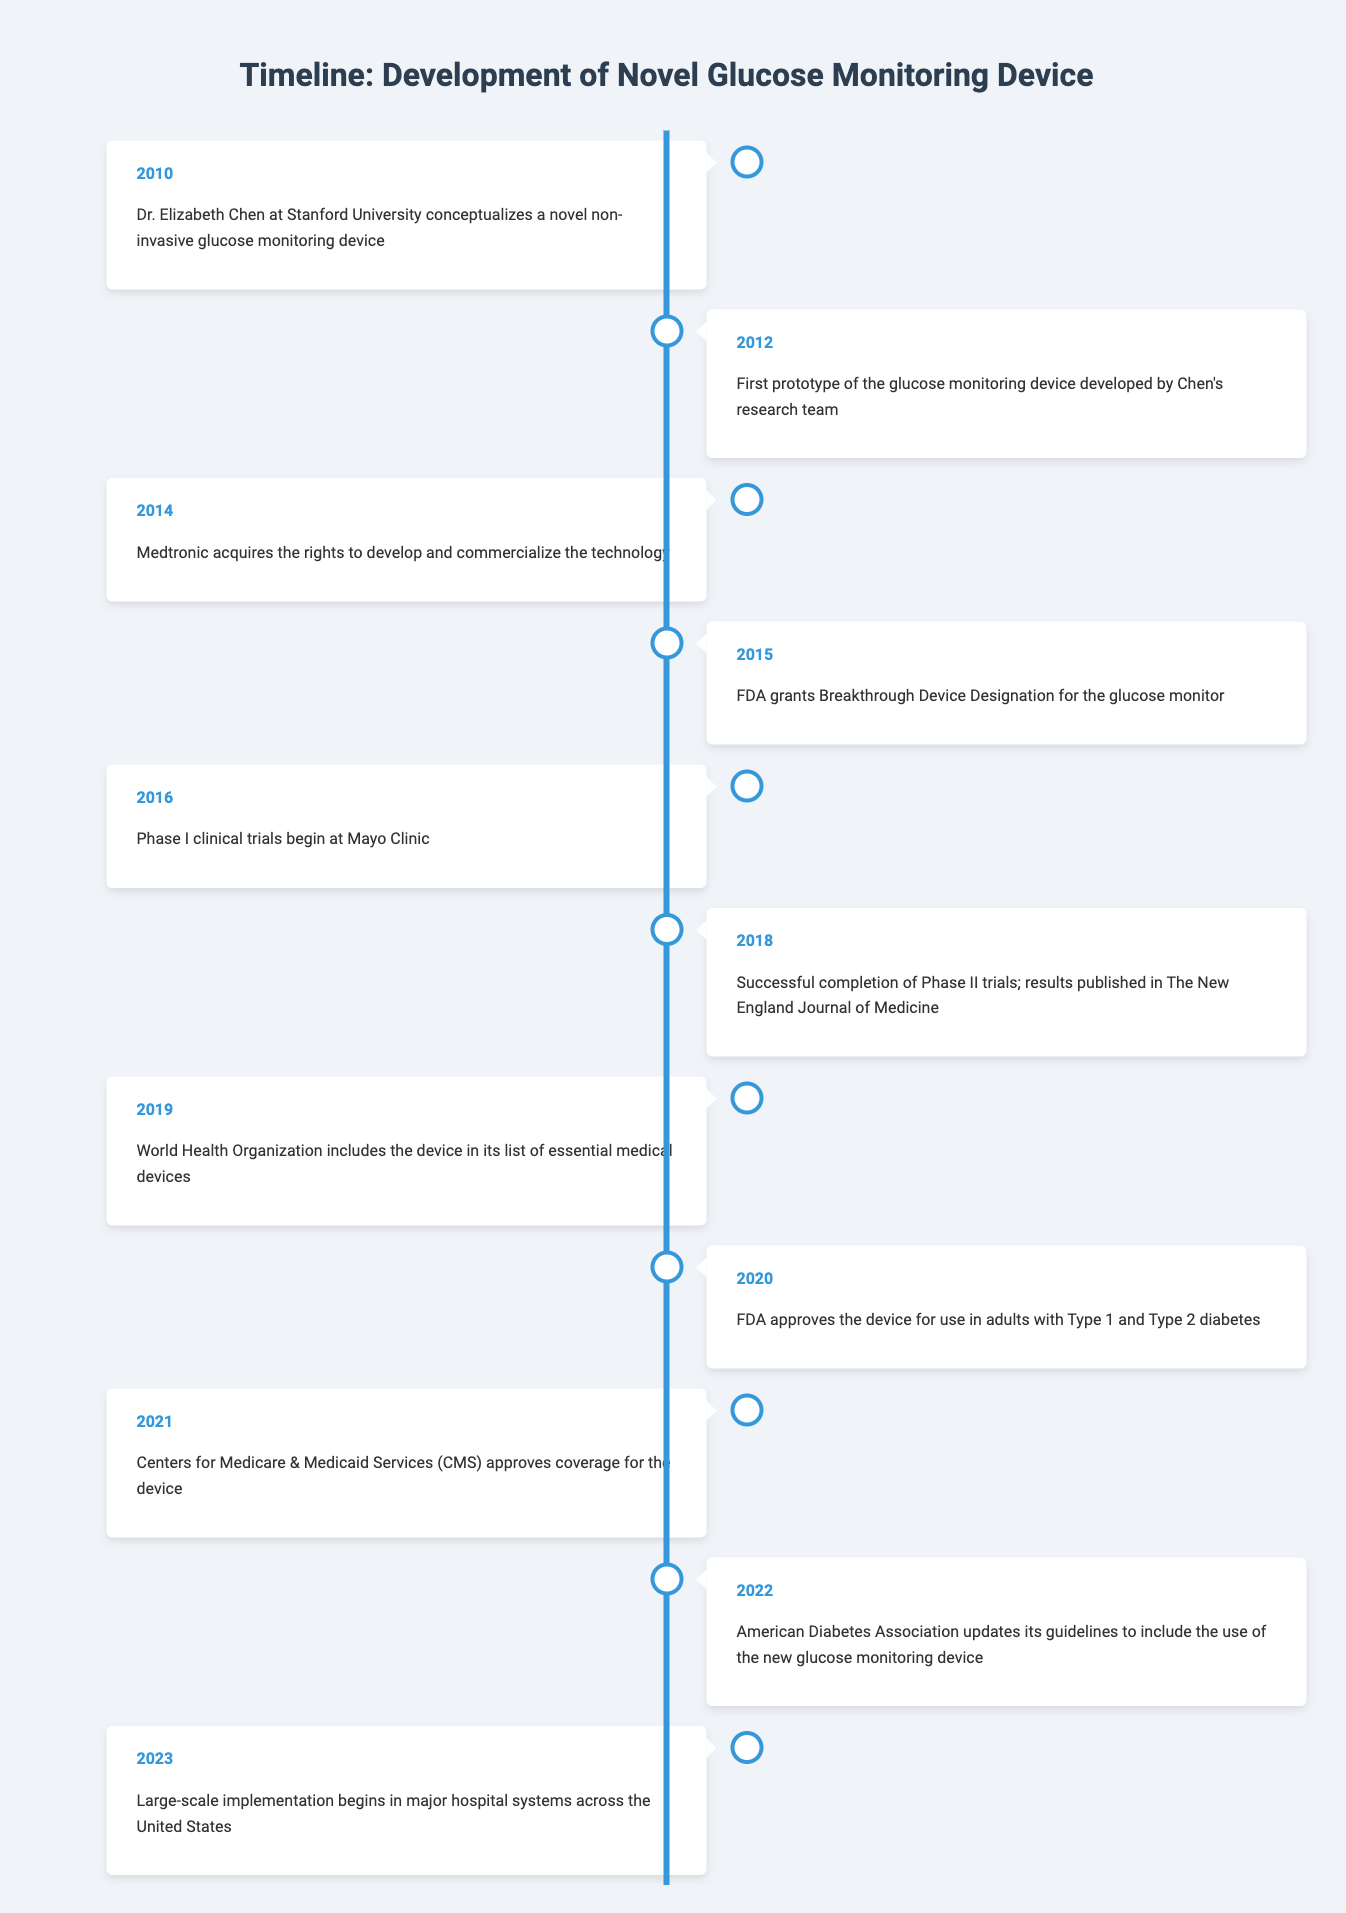What year was the first prototype of the glucose monitoring device developed? The table indicates that the first prototype was developed in 2012. This is directly stated in the event description for that year.
Answer: 2012 Which organization included the glucose monitoring device in its list of essential medical devices? The World Health Organization is mentioned in the entry for 2019, where it states that the device was included in its list.
Answer: World Health Organization How many years passed from the conceptualization of the device to its FDA approval? The device was conceptualized in 2010 and received FDA approval in 2020. To find the number of years passed, we subtract 2010 from 2020, which gives us 10 years.
Answer: 10 years Did the Centers for Medicare & Medicaid Services approve coverage for the device before its FDA approval? The timeline shows that the FDA approved the device in 2020, while CMS approval occurred in 2021. Therefore, CMS approval came after FDA approval.
Answer: No What is the chronological order of key events from the beginning of clinical trials to the conclusion of large-scale implementation? Phase I clinical trials began in 2016, followed by successful completion of Phase II trials in 2018, and large-scale implementation began in 2023. The proper order is: Phase I (2016), Phase II (2018), Large-scale Implementation (2023).
Answer: Phase I (2016), Phase II (2018), Large-scale Implementation (2023) 